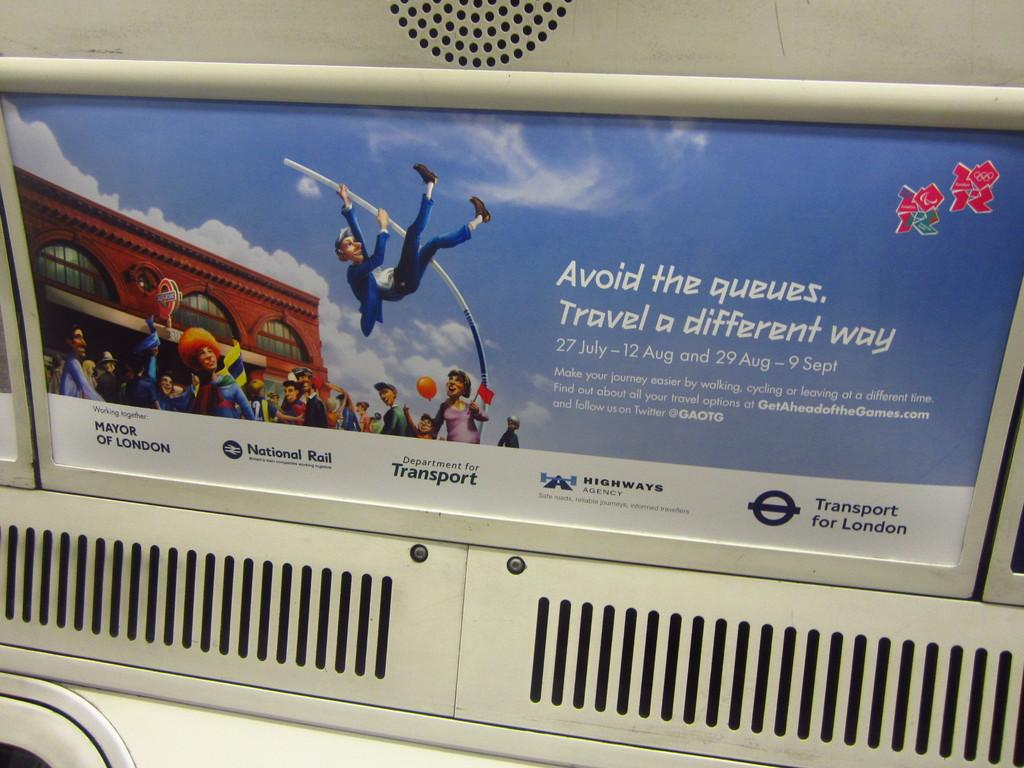What is displayed on the wall in the center of the image? There is an advertisement on the wall in the center of the image. Can you describe anything in the background of the image? Yes, there is a speaker in the background of the image. What type of scissors can be seen cutting the advertisement in the image? There are no scissors present in the image, and the advertisement is not being cut. How many toes are visible on the speaker in the image? There are no toes visible in the image, as the speaker is an inanimate object and not a person or living creature. 